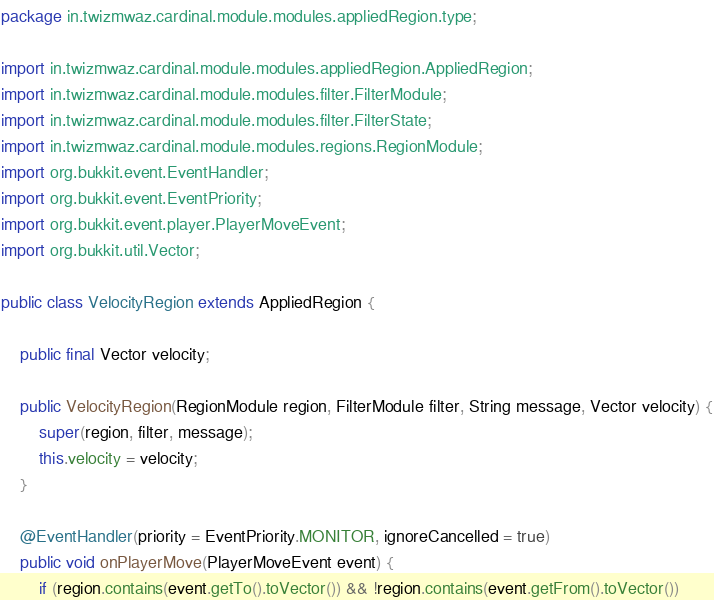Convert code to text. <code><loc_0><loc_0><loc_500><loc_500><_Java_>package in.twizmwaz.cardinal.module.modules.appliedRegion.type;

import in.twizmwaz.cardinal.module.modules.appliedRegion.AppliedRegion;
import in.twizmwaz.cardinal.module.modules.filter.FilterModule;
import in.twizmwaz.cardinal.module.modules.filter.FilterState;
import in.twizmwaz.cardinal.module.modules.regions.RegionModule;
import org.bukkit.event.EventHandler;
import org.bukkit.event.EventPriority;
import org.bukkit.event.player.PlayerMoveEvent;
import org.bukkit.util.Vector;

public class VelocityRegion extends AppliedRegion {

    public final Vector velocity;

    public VelocityRegion(RegionModule region, FilterModule filter, String message, Vector velocity) {
        super(region, filter, message);
        this.velocity = velocity;
    }

    @EventHandler(priority = EventPriority.MONITOR, ignoreCancelled = true)
    public void onPlayerMove(PlayerMoveEvent event) {
        if (region.contains(event.getTo().toVector()) && !region.contains(event.getFrom().toVector())</code> 